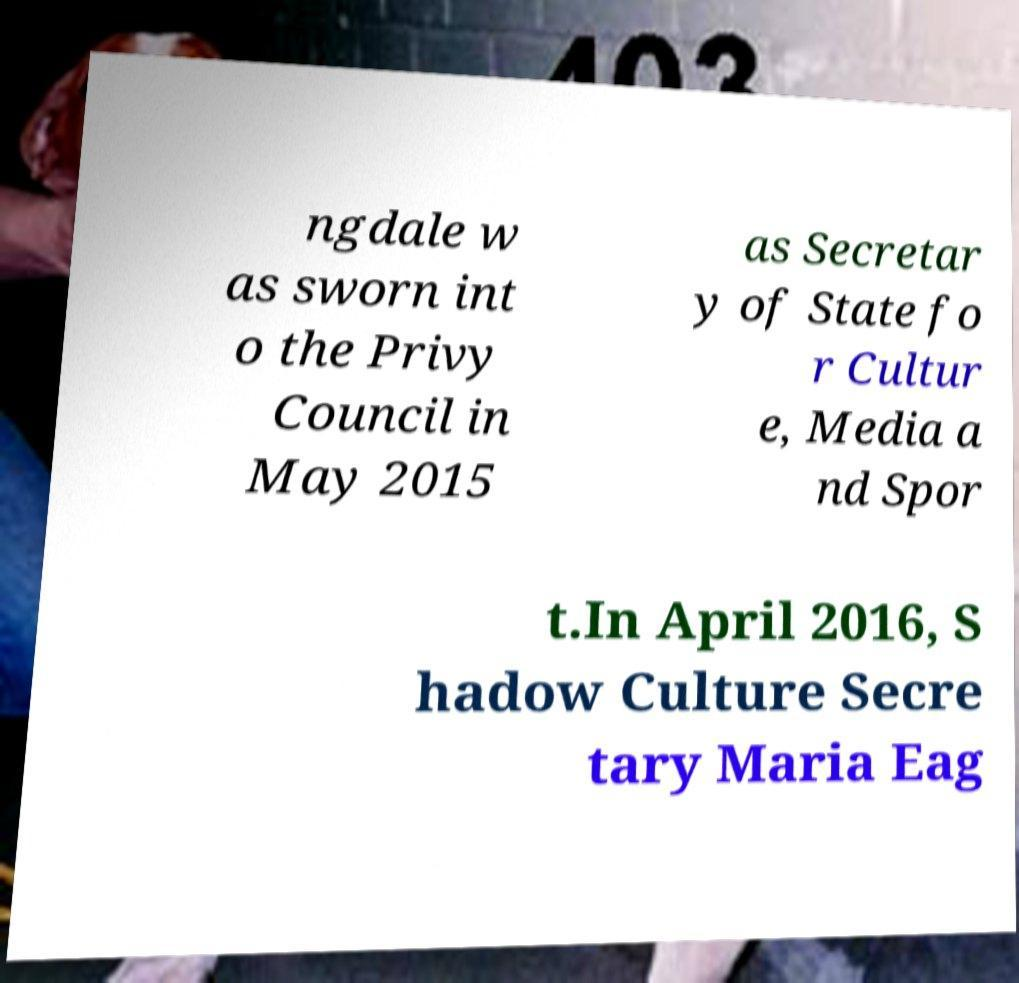Can you accurately transcribe the text from the provided image for me? ngdale w as sworn int o the Privy Council in May 2015 as Secretar y of State fo r Cultur e, Media a nd Spor t.In April 2016, S hadow Culture Secre tary Maria Eag 